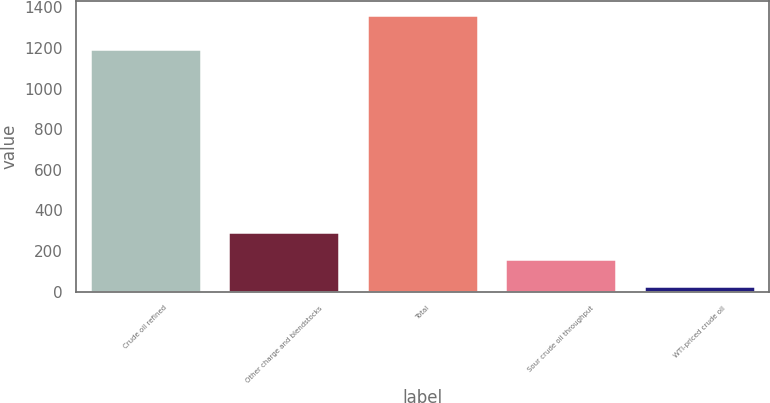Convert chart to OTSL. <chart><loc_0><loc_0><loc_500><loc_500><bar_chart><fcel>Crude oil refined<fcel>Other charge and blendstocks<fcel>Total<fcel>Sour crude oil throughput<fcel>WTI-priced crude oil<nl><fcel>1195<fcel>295<fcel>1363<fcel>161.5<fcel>28<nl></chart> 